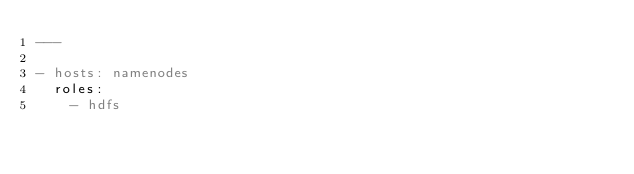<code> <loc_0><loc_0><loc_500><loc_500><_YAML_>---

- hosts: namenodes
  roles:
    - hdfs
</code> 